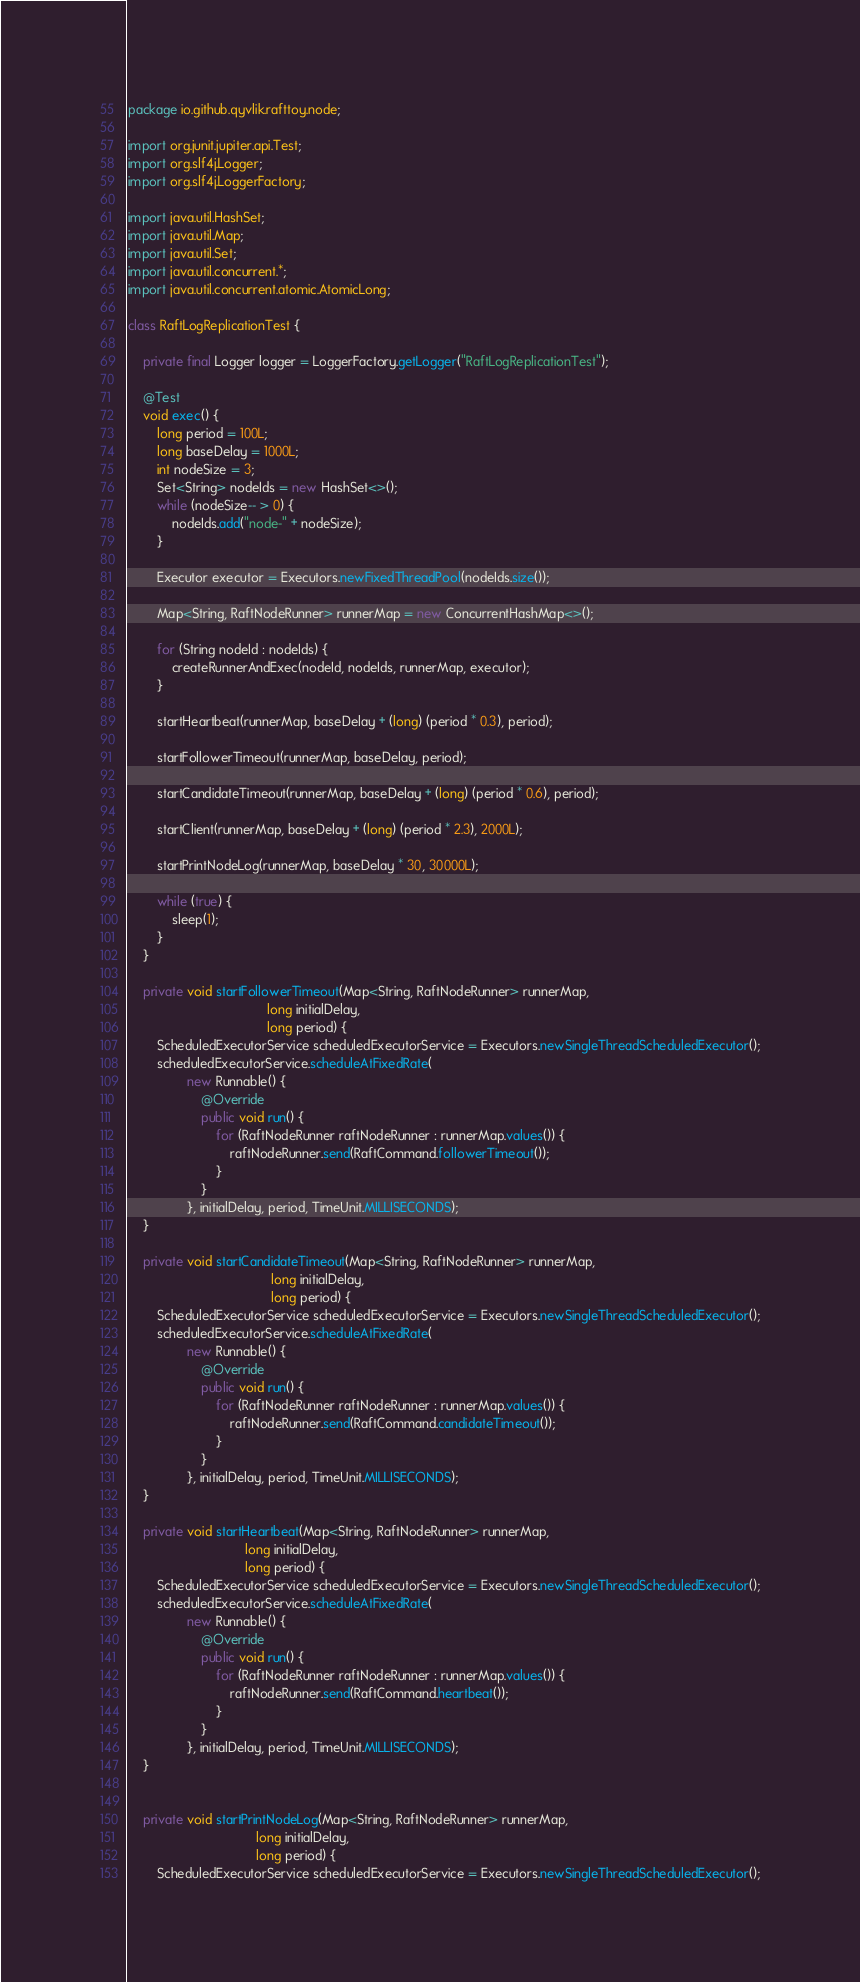Convert code to text. <code><loc_0><loc_0><loc_500><loc_500><_Java_>package io.github.qyvlik.rafttoy.node;

import org.junit.jupiter.api.Test;
import org.slf4j.Logger;
import org.slf4j.LoggerFactory;

import java.util.HashSet;
import java.util.Map;
import java.util.Set;
import java.util.concurrent.*;
import java.util.concurrent.atomic.AtomicLong;

class RaftLogReplicationTest {

    private final Logger logger = LoggerFactory.getLogger("RaftLogReplicationTest");

    @Test
    void exec() {
        long period = 100L;
        long baseDelay = 1000L;
        int nodeSize = 3;
        Set<String> nodeIds = new HashSet<>();
        while (nodeSize-- > 0) {
            nodeIds.add("node-" + nodeSize);
        }

        Executor executor = Executors.newFixedThreadPool(nodeIds.size());

        Map<String, RaftNodeRunner> runnerMap = new ConcurrentHashMap<>();

        for (String nodeId : nodeIds) {
            createRunnerAndExec(nodeId, nodeIds, runnerMap, executor);
        }

        startHeartbeat(runnerMap, baseDelay + (long) (period * 0.3), period);

        startFollowerTimeout(runnerMap, baseDelay, period);

        startCandidateTimeout(runnerMap, baseDelay + (long) (period * 0.6), period);

        startClient(runnerMap, baseDelay + (long) (period * 2.3), 2000L);

        startPrintNodeLog(runnerMap, baseDelay * 30, 30000L);

        while (true) {
            sleep(1);
        }
    }

    private void startFollowerTimeout(Map<String, RaftNodeRunner> runnerMap,
                                      long initialDelay,
                                      long period) {
        ScheduledExecutorService scheduledExecutorService = Executors.newSingleThreadScheduledExecutor();
        scheduledExecutorService.scheduleAtFixedRate(
                new Runnable() {
                    @Override
                    public void run() {
                        for (RaftNodeRunner raftNodeRunner : runnerMap.values()) {
                            raftNodeRunner.send(RaftCommand.followerTimeout());
                        }
                    }
                }, initialDelay, period, TimeUnit.MILLISECONDS);
    }

    private void startCandidateTimeout(Map<String, RaftNodeRunner> runnerMap,
                                       long initialDelay,
                                       long period) {
        ScheduledExecutorService scheduledExecutorService = Executors.newSingleThreadScheduledExecutor();
        scheduledExecutorService.scheduleAtFixedRate(
                new Runnable() {
                    @Override
                    public void run() {
                        for (RaftNodeRunner raftNodeRunner : runnerMap.values()) {
                            raftNodeRunner.send(RaftCommand.candidateTimeout());
                        }
                    }
                }, initialDelay, period, TimeUnit.MILLISECONDS);
    }

    private void startHeartbeat(Map<String, RaftNodeRunner> runnerMap,
                                long initialDelay,
                                long period) {
        ScheduledExecutorService scheduledExecutorService = Executors.newSingleThreadScheduledExecutor();
        scheduledExecutorService.scheduleAtFixedRate(
                new Runnable() {
                    @Override
                    public void run() {
                        for (RaftNodeRunner raftNodeRunner : runnerMap.values()) {
                            raftNodeRunner.send(RaftCommand.heartbeat());
                        }
                    }
                }, initialDelay, period, TimeUnit.MILLISECONDS);
    }


    private void startPrintNodeLog(Map<String, RaftNodeRunner> runnerMap,
                                   long initialDelay,
                                   long period) {
        ScheduledExecutorService scheduledExecutorService = Executors.newSingleThreadScheduledExecutor();</code> 